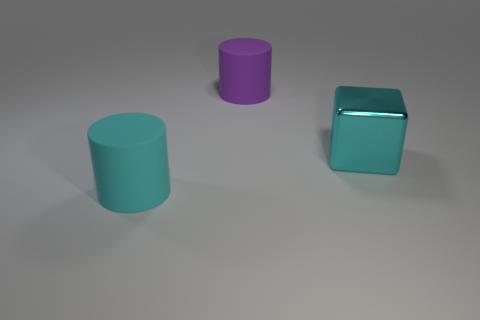Are there any other things that are the same shape as the cyan shiny thing?
Provide a short and direct response. No. There is a big thing that is both in front of the large purple matte cylinder and on the left side of the metal block; what material is it made of?
Provide a succinct answer. Rubber. Does the cyan cylinder have the same material as the big cyan thing on the right side of the large purple matte object?
Keep it short and to the point. No. What number of objects are cyan metallic blocks or large rubber things that are behind the big metallic cube?
Give a very brief answer. 2. How many other objects are the same color as the large block?
Give a very brief answer. 1. There is a purple rubber cylinder; does it have the same size as the cyan thing behind the large cyan rubber cylinder?
Keep it short and to the point. Yes. There is a rubber cylinder in front of the big rubber object to the right of the large cyan matte object; what size is it?
Give a very brief answer. Large. What is the color of the other large matte object that is the same shape as the big purple matte object?
Provide a succinct answer. Cyan. Do the purple rubber thing and the cyan cylinder have the same size?
Your answer should be compact. Yes. Is the number of big cyan metallic objects that are in front of the cyan rubber cylinder the same as the number of big cyan cylinders?
Your answer should be very brief. No. 